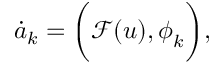<formula> <loc_0><loc_0><loc_500><loc_500>\dot { a } _ { k } = \left ( \mathcal { F } ( u ) , \phi _ { k } \right ) ,</formula> 